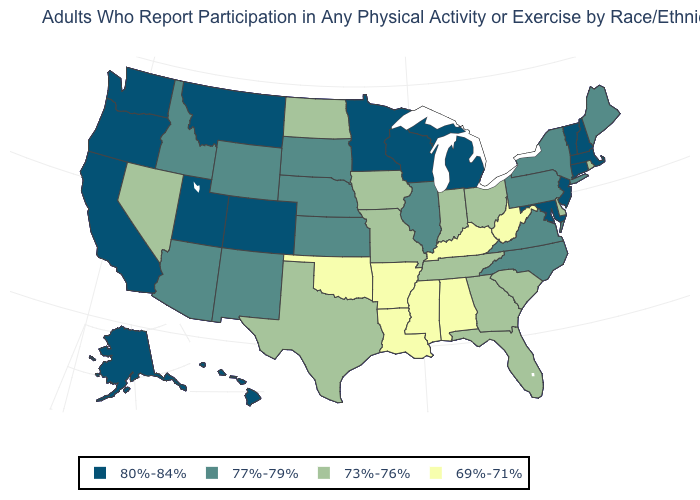What is the value of California?
Short answer required. 80%-84%. What is the value of Maine?
Be succinct. 77%-79%. Name the states that have a value in the range 73%-76%?
Give a very brief answer. Delaware, Florida, Georgia, Indiana, Iowa, Missouri, Nevada, North Dakota, Ohio, Rhode Island, South Carolina, Tennessee, Texas. Does the first symbol in the legend represent the smallest category?
Be succinct. No. Does Rhode Island have the highest value in the Northeast?
Quick response, please. No. Which states hav the highest value in the MidWest?
Give a very brief answer. Michigan, Minnesota, Wisconsin. Is the legend a continuous bar?
Keep it brief. No. Name the states that have a value in the range 69%-71%?
Write a very short answer. Alabama, Arkansas, Kentucky, Louisiana, Mississippi, Oklahoma, West Virginia. What is the highest value in states that border Connecticut?
Write a very short answer. 80%-84%. Name the states that have a value in the range 73%-76%?
Answer briefly. Delaware, Florida, Georgia, Indiana, Iowa, Missouri, Nevada, North Dakota, Ohio, Rhode Island, South Carolina, Tennessee, Texas. Name the states that have a value in the range 73%-76%?
Concise answer only. Delaware, Florida, Georgia, Indiana, Iowa, Missouri, Nevada, North Dakota, Ohio, Rhode Island, South Carolina, Tennessee, Texas. Which states have the highest value in the USA?
Give a very brief answer. Alaska, California, Colorado, Connecticut, Hawaii, Maryland, Massachusetts, Michigan, Minnesota, Montana, New Hampshire, New Jersey, Oregon, Utah, Vermont, Washington, Wisconsin. What is the value of Nevada?
Answer briefly. 73%-76%. Does Louisiana have the lowest value in the USA?
Write a very short answer. Yes. Does Georgia have the same value as Montana?
Give a very brief answer. No. 